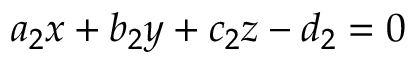Convert formula to latex. <formula><loc_0><loc_0><loc_500><loc_500>a _ { 2 } x + b _ { 2 } y + c _ { 2 } z - d _ { 2 } = 0</formula> 